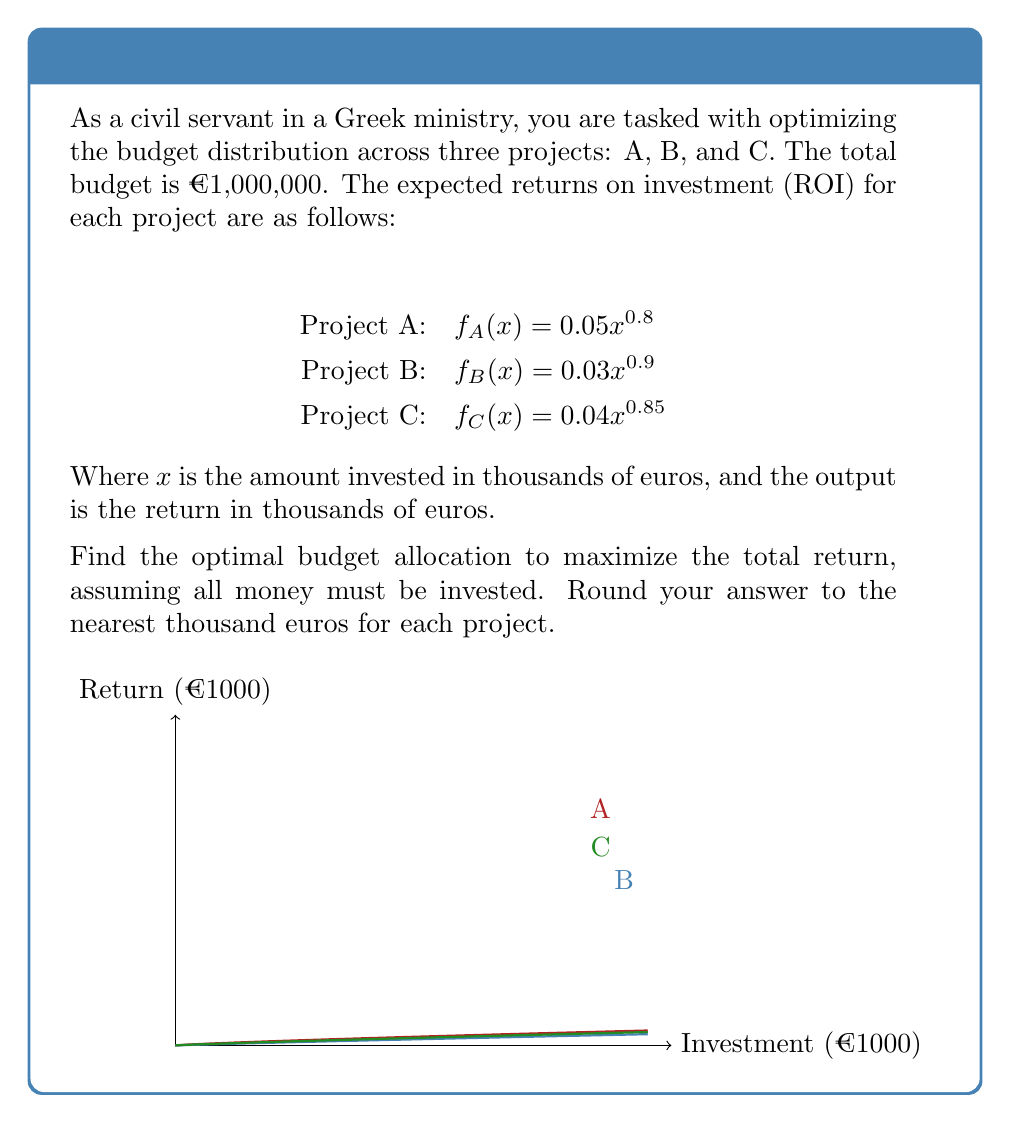Could you help me with this problem? To solve this optimization problem, we'll use the method of Lagrange multipliers:

1) Let $x$, $y$, and $z$ be the investments in projects A, B, and C respectively (in thousands of euros).

2) Our objective function is:
   $f(x,y,z) = 0.05x^{0.8} + 0.03y^{0.9} + 0.04z^{0.85}$

3) The constraint is:
   $g(x,y,z) = x + y + z - 1000 = 0$

4) Form the Lagrangian:
   $L(x,y,z,\lambda) = f(x,y,z) - \lambda g(x,y,z)$

5) Set partial derivatives to zero:
   $\frac{\partial L}{\partial x} = 0.04x^{-0.2} - \lambda = 0$
   $\frac{\partial L}{\partial y} = 0.027y^{-0.1} - \lambda = 0$
   $\frac{\partial L}{\partial z} = 0.034z^{-0.15} - \lambda = 0$
   $\frac{\partial L}{\partial \lambda} = x + y + z - 1000 = 0$

6) From these equations:
   $x^{-0.2} = 25\lambda$
   $y^{-0.1} = 37.037\lambda$
   $z^{-0.15} = 29.412\lambda$

7) Raise to appropriate powers:
   $x = (25\lambda)^{-5}$
   $y = (37.037\lambda)^{-10}$
   $z = (29.412\lambda)^{-6.667}$

8) Substitute into constraint:
   $(25\lambda)^{-5} + (37.037\lambda)^{-10} + (29.412\lambda)^{-6.667} = 1000$

9) Solve numerically for $\lambda$ (approximately 0.002356)

10) Substitute back to find $x$, $y$, and $z$:
    $x \approx 457.8$
    $y \approx 284.7$
    $z \approx 257.5$

11) Rounding to the nearest thousand:
    A: €458,000
    B: €285,000
    C: €257,000
Answer: A: €458,000, B: €285,000, C: €257,000 